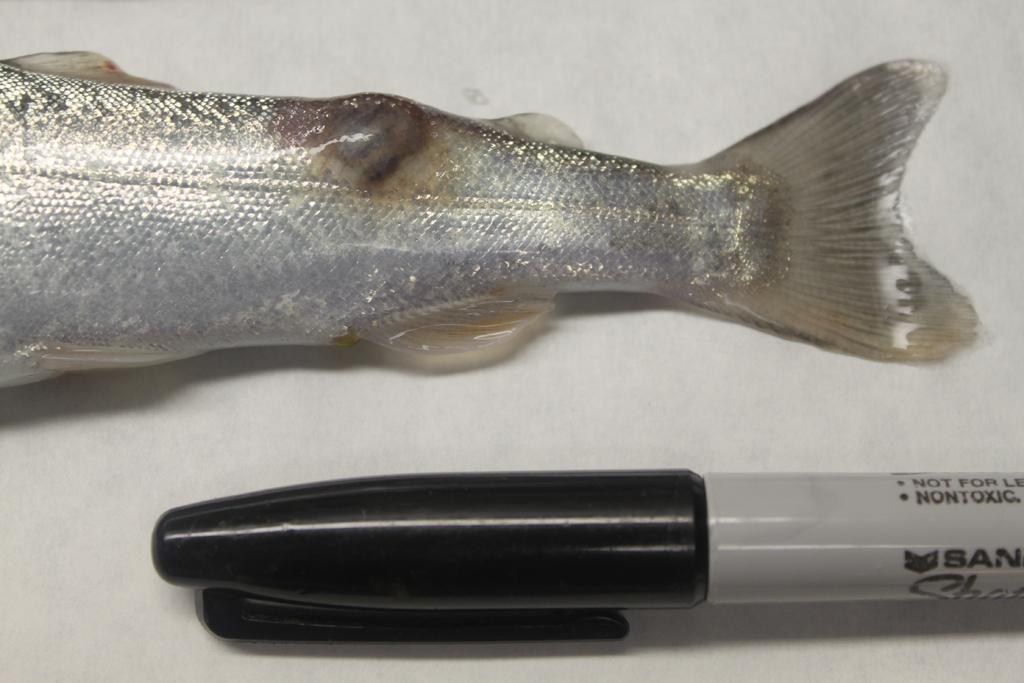Please provide a concise description of this image. In the image there is a fish on a table beside a marker. 